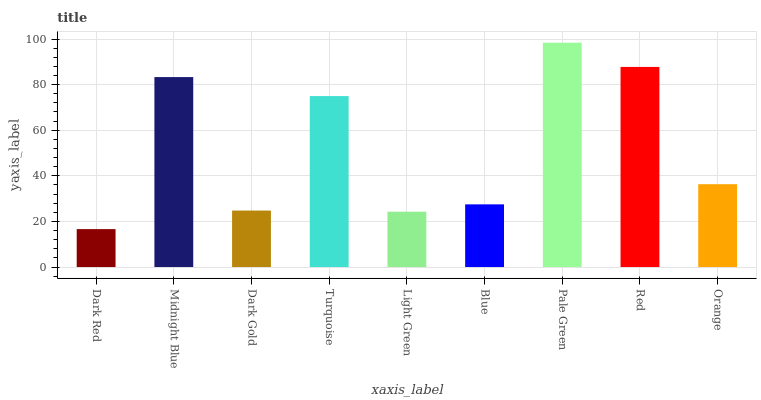Is Midnight Blue the minimum?
Answer yes or no. No. Is Midnight Blue the maximum?
Answer yes or no. No. Is Midnight Blue greater than Dark Red?
Answer yes or no. Yes. Is Dark Red less than Midnight Blue?
Answer yes or no. Yes. Is Dark Red greater than Midnight Blue?
Answer yes or no. No. Is Midnight Blue less than Dark Red?
Answer yes or no. No. Is Orange the high median?
Answer yes or no. Yes. Is Orange the low median?
Answer yes or no. Yes. Is Light Green the high median?
Answer yes or no. No. Is Pale Green the low median?
Answer yes or no. No. 